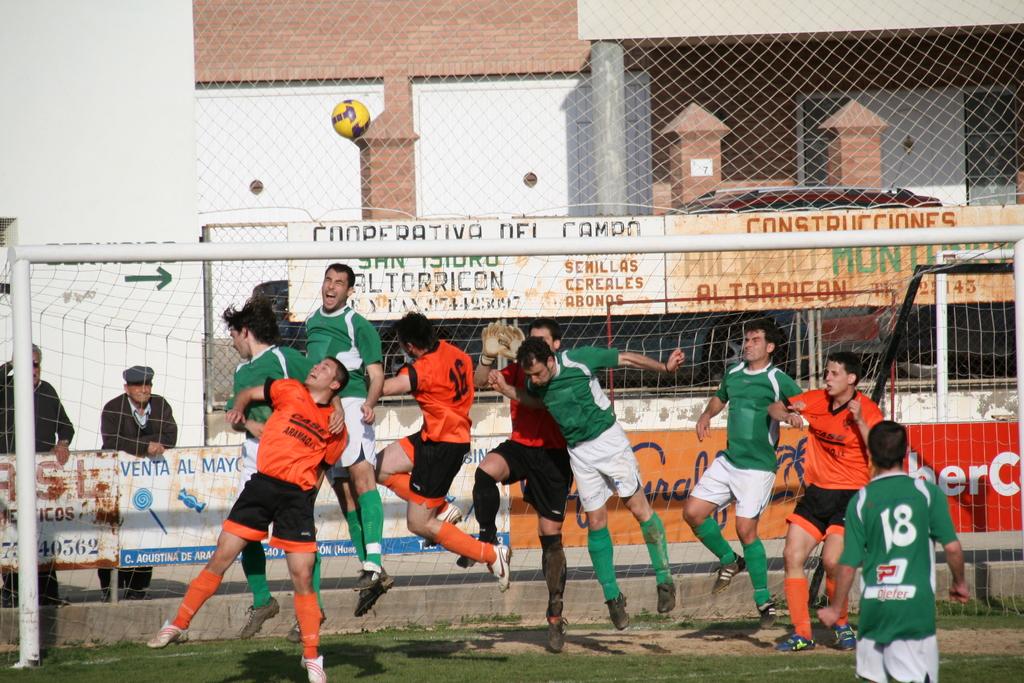Can you see the word cooperative on the board behind the footballers?
Your answer should be compact. Yes. What is the number of the player in the green jersey facing away?
Your response must be concise. 18. 